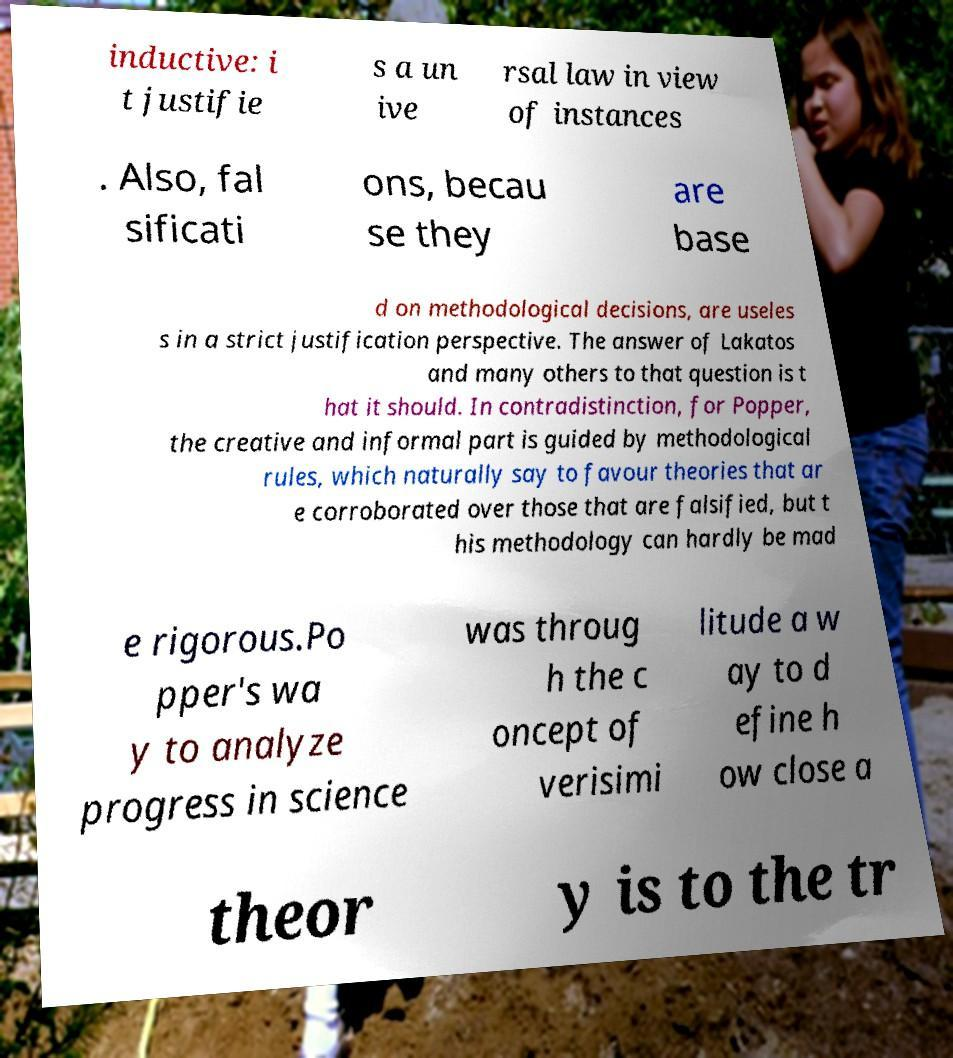Please read and relay the text visible in this image. What does it say? inductive: i t justifie s a un ive rsal law in view of instances . Also, fal sificati ons, becau se they are base d on methodological decisions, are useles s in a strict justification perspective. The answer of Lakatos and many others to that question is t hat it should. In contradistinction, for Popper, the creative and informal part is guided by methodological rules, which naturally say to favour theories that ar e corroborated over those that are falsified, but t his methodology can hardly be mad e rigorous.Po pper's wa y to analyze progress in science was throug h the c oncept of verisimi litude a w ay to d efine h ow close a theor y is to the tr 